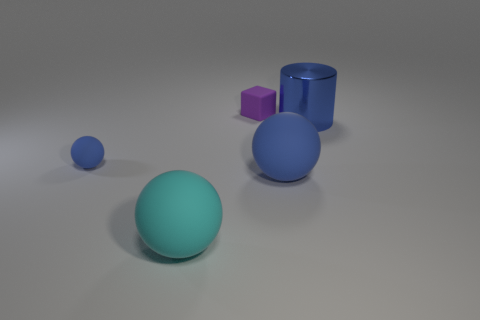How many spheres are the same color as the metallic object?
Keep it short and to the point. 2. There is a sphere to the right of the cyan matte object in front of the tiny matte thing that is left of the matte cube; what is its size?
Give a very brief answer. Large. How many matte objects are either big blue cylinders or blue spheres?
Provide a short and direct response. 2. There is a large cyan matte object; is it the same shape as the tiny rubber object that is behind the large metallic cylinder?
Your answer should be very brief. No. Are there more small rubber objects that are in front of the metal cylinder than big blue metal cylinders that are in front of the cyan rubber object?
Keep it short and to the point. Yes. Is there any other thing that has the same color as the cylinder?
Ensure brevity in your answer.  Yes. There is a small object behind the tiny object to the left of the cyan object; is there a ball that is left of it?
Your response must be concise. Yes. Do the tiny matte object that is in front of the blue cylinder and the large blue matte object have the same shape?
Offer a very short reply. Yes. Is the number of small purple matte cubes that are on the right side of the purple thing less than the number of blue spheres that are on the right side of the tiny blue matte ball?
Offer a terse response. Yes. What material is the block?
Provide a succinct answer. Rubber. 